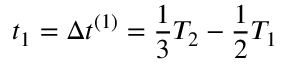<formula> <loc_0><loc_0><loc_500><loc_500>t _ { 1 } = \Delta t ^ { ( 1 ) } = \frac { 1 } { 3 } T _ { 2 } - \frac { 1 } { 2 } T _ { 1 }</formula> 